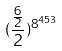Convert formula to latex. <formula><loc_0><loc_0><loc_500><loc_500>( \frac { \frac { 6 } { 2 } } { 2 } ) ^ { 8 ^ { 4 5 3 } }</formula> 